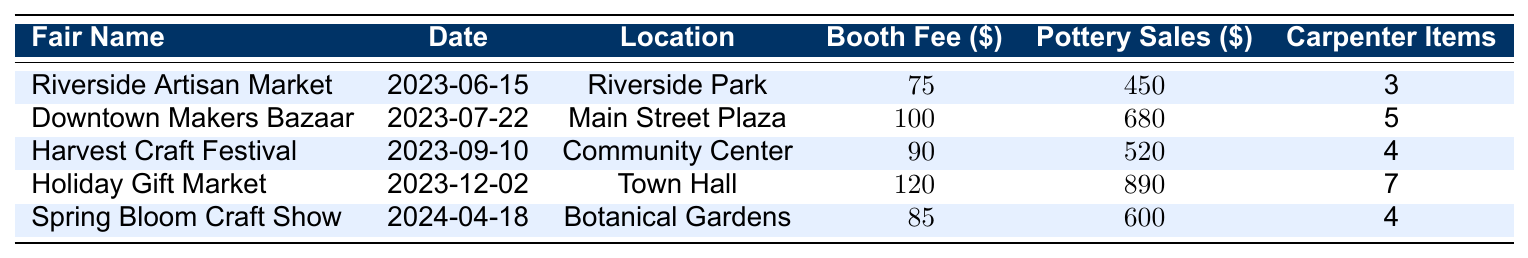What is the booth fee for the Holiday Gift Market? The booth fee for the Holiday Gift Market is listed directly in the table as $120.
Answer: 120 How much pottery was sold at the Downtown Makers Bazaar? The pottery sales for the Downtown Makers Bazaar is shown in the table as $680.
Answer: 680 What is the total pottery sales from all craft fairs listed? The total pottery sales can be calculated by summing each fair's sales: 450 + 680 + 520 + 890 + 600 = 3140.
Answer: 3140 Which fair had the highest booth fee? By looking at the booth fees in the table, the Holiday Gift Market has the highest fee at $120.
Answer: Holiday Gift Market How many carpenter items were sold in total across all craft fairs? To find the total number of carpenter items sold, add the items sold at each fair: 3 + 5 + 4 + 7 + 4 = 23.
Answer: 23 What was the average booth fee for the fairs? The average booth fee is calculated by summing the fees ($75 + $100 + $90 + $120 + $85 = 470) and dividing by the number of fairs (5): 470 / 5 = 94.
Answer: 94 Is the pottery sales amount at the Riverside Artisan Market greater than $400? The pottery sales for the Riverside Artisan Market is $450, which is greater than $400, so the statement is true.
Answer: Yes Which fair had the lowest pottery sales? Looking at the pottery sales figures, the Riverside Artisan Market had the lowest sales at $450.
Answer: Riverside Artisan Market How much more did pottery sales at the Holiday Gift Market exceed those at the Harvest Craft Festival? The pottery sales at the Holiday Gift Market is $890 and at the Harvest Craft Festival is $520. The difference is $890 - $520 = $370.
Answer: 370 Which market had more pottery sales: Spring Bloom Craft Show or Riverside Artisan Market? The pottery sales at the Spring Bloom Craft Show is $600 and at the Riverside Artisan Market is $450. Since $600 is greater than $450, the Spring Bloom Craft Show had more sales.
Answer: Spring Bloom Craft Show 